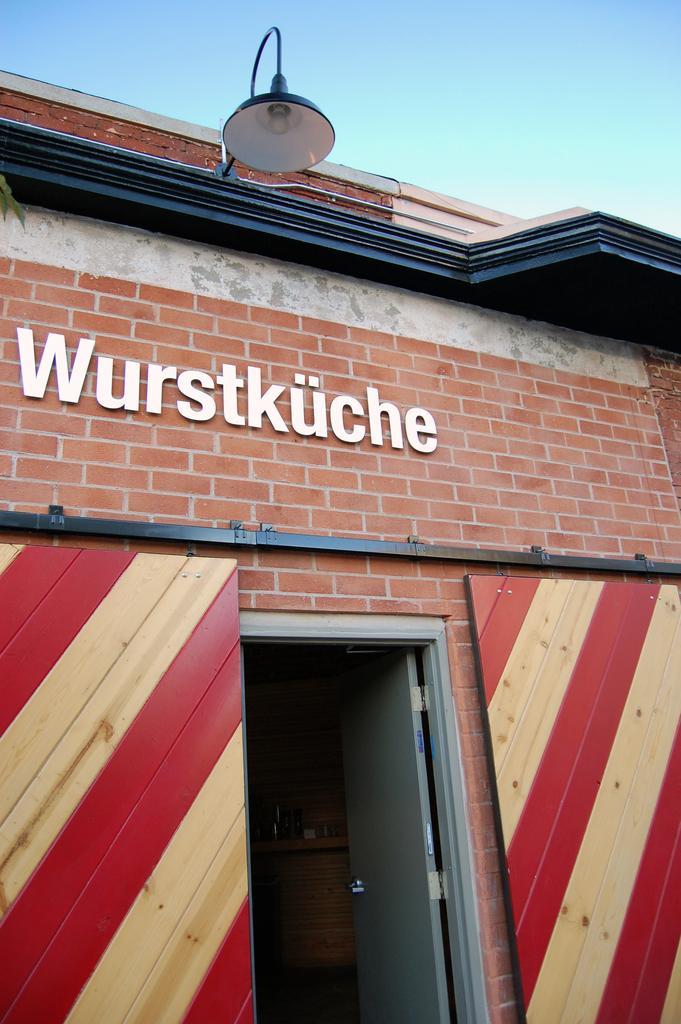Can you describe this image briefly? In this image there is a building and we can see a door. At the top there is a light and we can see the sky. 